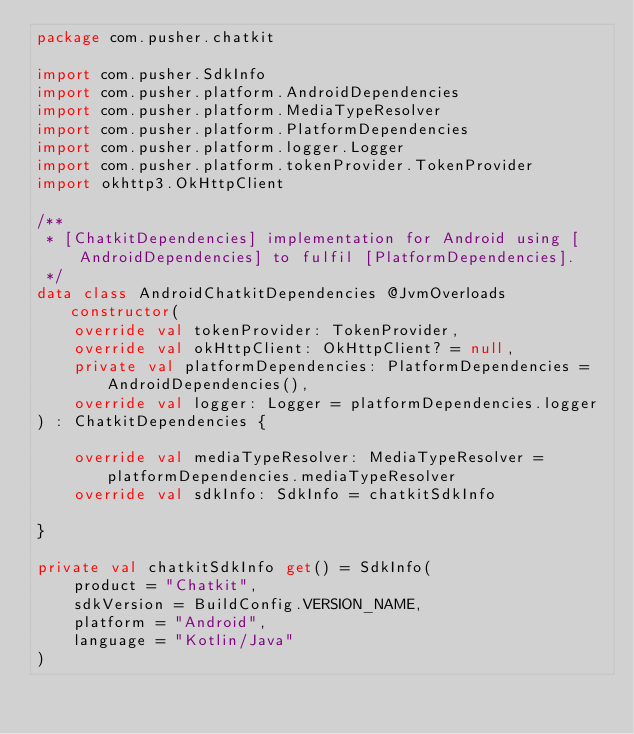<code> <loc_0><loc_0><loc_500><loc_500><_Kotlin_>package com.pusher.chatkit

import com.pusher.SdkInfo
import com.pusher.platform.AndroidDependencies
import com.pusher.platform.MediaTypeResolver
import com.pusher.platform.PlatformDependencies
import com.pusher.platform.logger.Logger
import com.pusher.platform.tokenProvider.TokenProvider
import okhttp3.OkHttpClient

/**
 * [ChatkitDependencies] implementation for Android using [AndroidDependencies] to fulfil [PlatformDependencies].
 */
data class AndroidChatkitDependencies @JvmOverloads constructor(
    override val tokenProvider: TokenProvider,
    override val okHttpClient: OkHttpClient? = null,
    private val platformDependencies: PlatformDependencies = AndroidDependencies(),
    override val logger: Logger = platformDependencies.logger
) : ChatkitDependencies {

    override val mediaTypeResolver: MediaTypeResolver = platformDependencies.mediaTypeResolver
    override val sdkInfo: SdkInfo = chatkitSdkInfo

}

private val chatkitSdkInfo get() = SdkInfo(
    product = "Chatkit",
    sdkVersion = BuildConfig.VERSION_NAME,
    platform = "Android",
    language = "Kotlin/Java"
)
</code> 